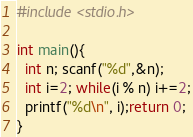Convert code to text. <code><loc_0><loc_0><loc_500><loc_500><_C++_>#include <stdio.h>

int main(){
  int n; scanf("%d",&n);
  int i=2; while(i % n) i+=2;
  printf("%d\n", i);return 0;
}</code> 